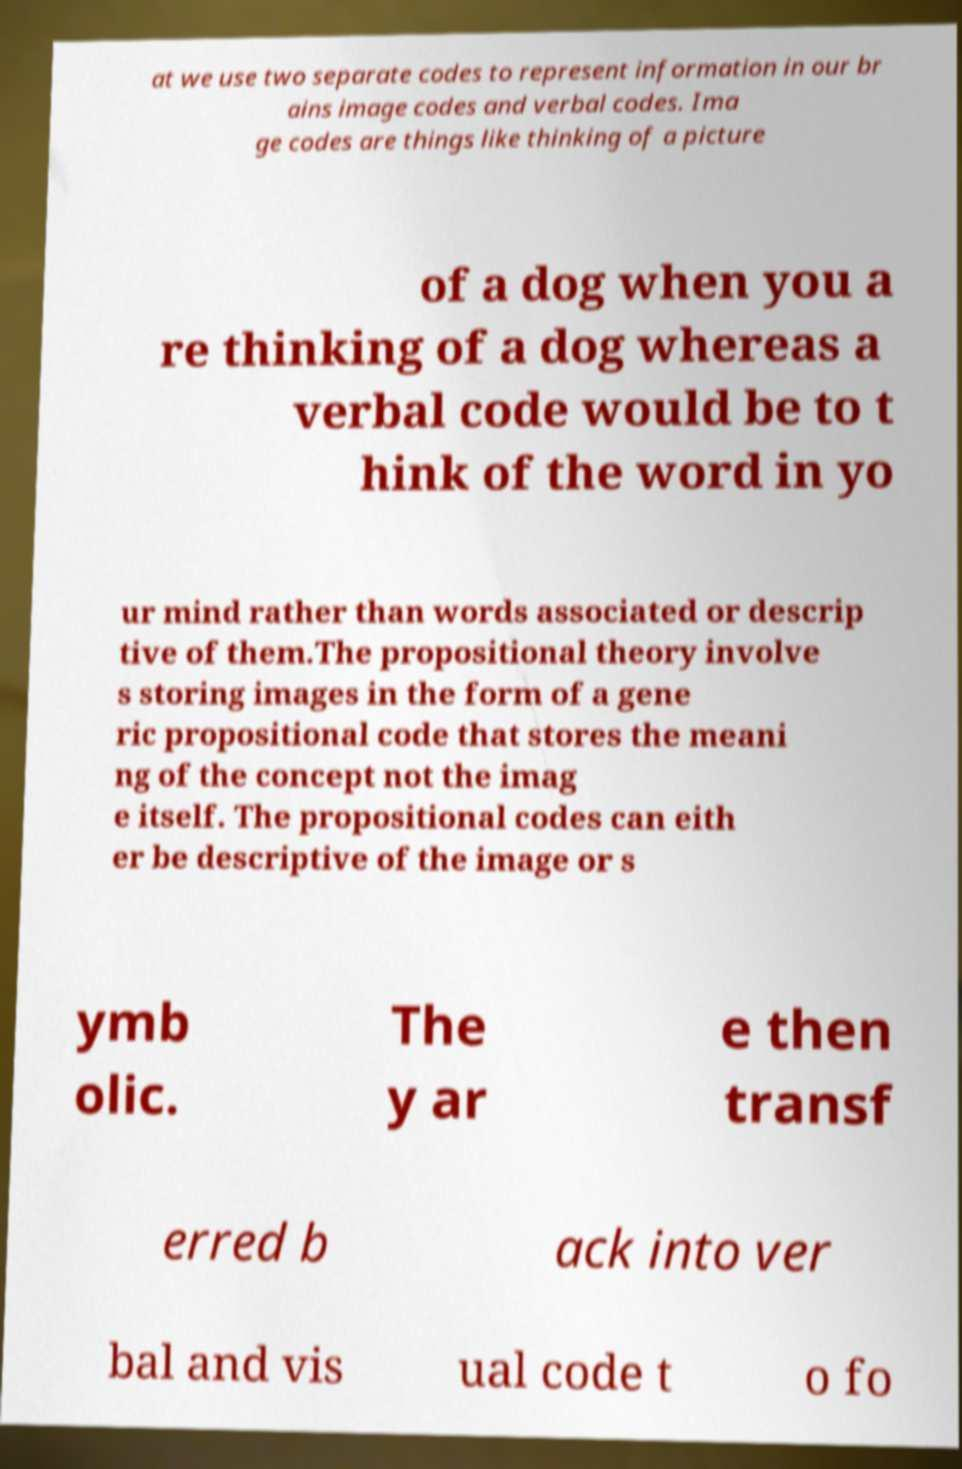What messages or text are displayed in this image? I need them in a readable, typed format. at we use two separate codes to represent information in our br ains image codes and verbal codes. Ima ge codes are things like thinking of a picture of a dog when you a re thinking of a dog whereas a verbal code would be to t hink of the word in yo ur mind rather than words associated or descrip tive of them.The propositional theory involve s storing images in the form of a gene ric propositional code that stores the meani ng of the concept not the imag e itself. The propositional codes can eith er be descriptive of the image or s ymb olic. The y ar e then transf erred b ack into ver bal and vis ual code t o fo 